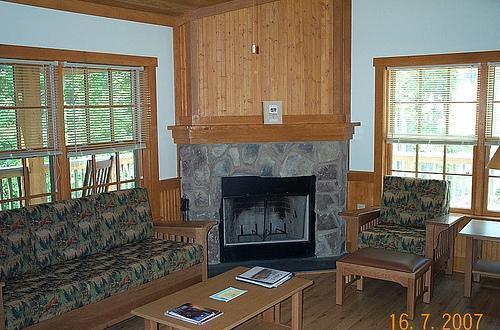How many couches are visible?
Give a very brief answer. 1. How many chairs are there?
Give a very brief answer. 2. How many squid-shaped kites can be seen?
Give a very brief answer. 0. 